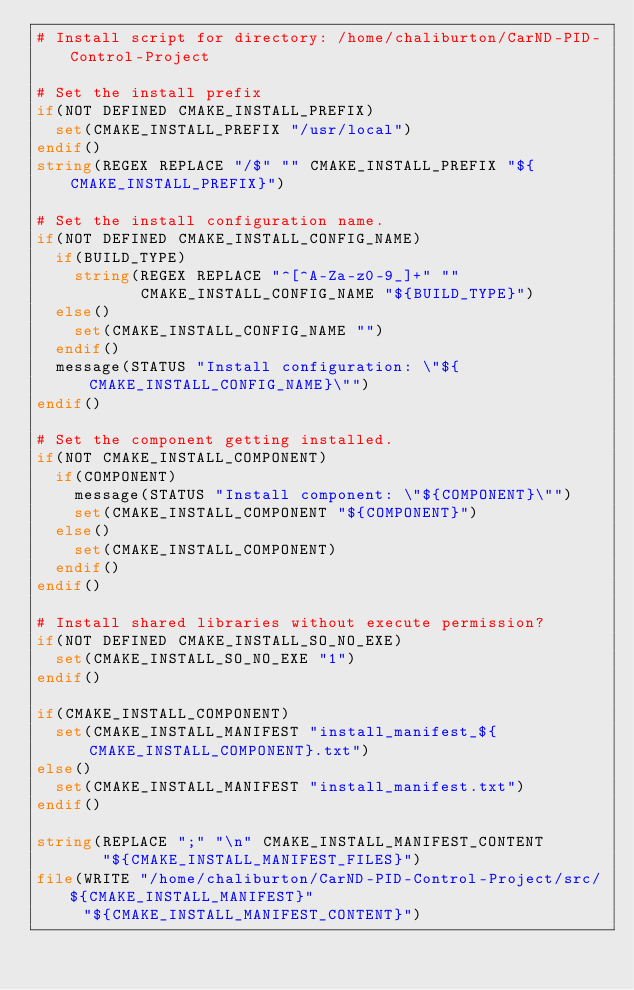<code> <loc_0><loc_0><loc_500><loc_500><_CMake_># Install script for directory: /home/chaliburton/CarND-PID-Control-Project

# Set the install prefix
if(NOT DEFINED CMAKE_INSTALL_PREFIX)
  set(CMAKE_INSTALL_PREFIX "/usr/local")
endif()
string(REGEX REPLACE "/$" "" CMAKE_INSTALL_PREFIX "${CMAKE_INSTALL_PREFIX}")

# Set the install configuration name.
if(NOT DEFINED CMAKE_INSTALL_CONFIG_NAME)
  if(BUILD_TYPE)
    string(REGEX REPLACE "^[^A-Za-z0-9_]+" ""
           CMAKE_INSTALL_CONFIG_NAME "${BUILD_TYPE}")
  else()
    set(CMAKE_INSTALL_CONFIG_NAME "")
  endif()
  message(STATUS "Install configuration: \"${CMAKE_INSTALL_CONFIG_NAME}\"")
endif()

# Set the component getting installed.
if(NOT CMAKE_INSTALL_COMPONENT)
  if(COMPONENT)
    message(STATUS "Install component: \"${COMPONENT}\"")
    set(CMAKE_INSTALL_COMPONENT "${COMPONENT}")
  else()
    set(CMAKE_INSTALL_COMPONENT)
  endif()
endif()

# Install shared libraries without execute permission?
if(NOT DEFINED CMAKE_INSTALL_SO_NO_EXE)
  set(CMAKE_INSTALL_SO_NO_EXE "1")
endif()

if(CMAKE_INSTALL_COMPONENT)
  set(CMAKE_INSTALL_MANIFEST "install_manifest_${CMAKE_INSTALL_COMPONENT}.txt")
else()
  set(CMAKE_INSTALL_MANIFEST "install_manifest.txt")
endif()

string(REPLACE ";" "\n" CMAKE_INSTALL_MANIFEST_CONTENT
       "${CMAKE_INSTALL_MANIFEST_FILES}")
file(WRITE "/home/chaliburton/CarND-PID-Control-Project/src/${CMAKE_INSTALL_MANIFEST}"
     "${CMAKE_INSTALL_MANIFEST_CONTENT}")
</code> 